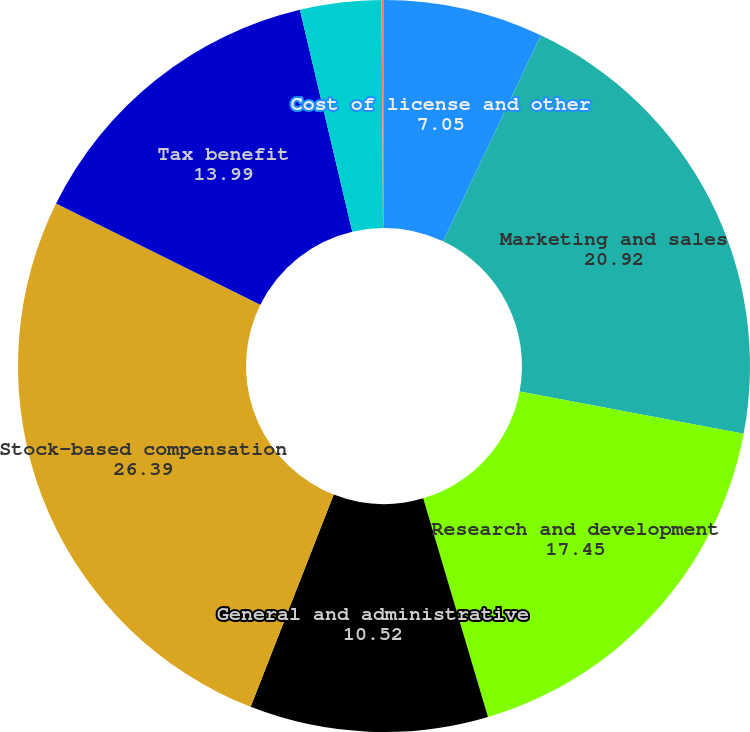Convert chart. <chart><loc_0><loc_0><loc_500><loc_500><pie_chart><fcel>Cost of license and other<fcel>Marketing and sales<fcel>Research and development<fcel>General and administrative<fcel>Stock-based compensation<fcel>Tax benefit<fcel>Basic<fcel>Diluted<nl><fcel>7.05%<fcel>20.92%<fcel>17.45%<fcel>10.52%<fcel>26.39%<fcel>13.99%<fcel>3.58%<fcel>0.11%<nl></chart> 